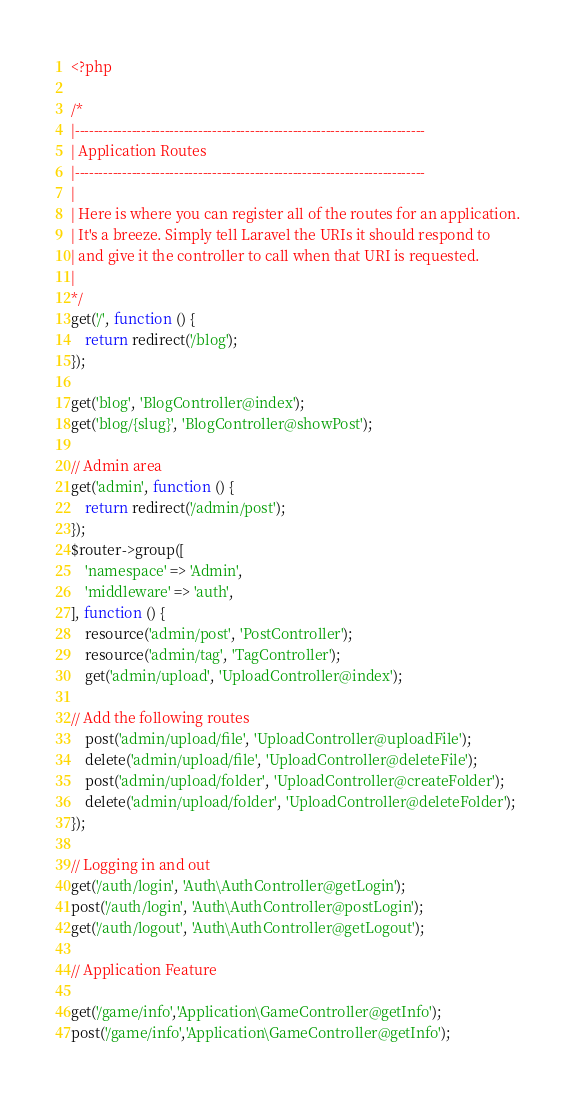<code> <loc_0><loc_0><loc_500><loc_500><_PHP_><?php

/*
|--------------------------------------------------------------------------
| Application Routes
|--------------------------------------------------------------------------
|
| Here is where you can register all of the routes for an application.
| It's a breeze. Simply tell Laravel the URIs it should respond to
| and give it the controller to call when that URI is requested.
|
*/
get('/', function () {
    return redirect('/blog');
});

get('blog', 'BlogController@index');
get('blog/{slug}', 'BlogController@showPost');

// Admin area
get('admin', function () {
    return redirect('/admin/post');
});
$router->group([
    'namespace' => 'Admin',
    'middleware' => 'auth',
], function () {
    resource('admin/post', 'PostController');
    resource('admin/tag', 'TagController');
    get('admin/upload', 'UploadController@index');

// Add the following routes
    post('admin/upload/file', 'UploadController@uploadFile');
    delete('admin/upload/file', 'UploadController@deleteFile');
    post('admin/upload/folder', 'UploadController@createFolder');
    delete('admin/upload/folder', 'UploadController@deleteFolder');
});

// Logging in and out
get('/auth/login', 'Auth\AuthController@getLogin');
post('/auth/login', 'Auth\AuthController@postLogin');
get('/auth/logout', 'Auth\AuthController@getLogout');

// Application Feature

get('/game/info','Application\GameController@getInfo');
post('/game/info','Application\GameController@getInfo');</code> 